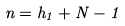<formula> <loc_0><loc_0><loc_500><loc_500>n = h _ { 1 } + N - 1</formula> 